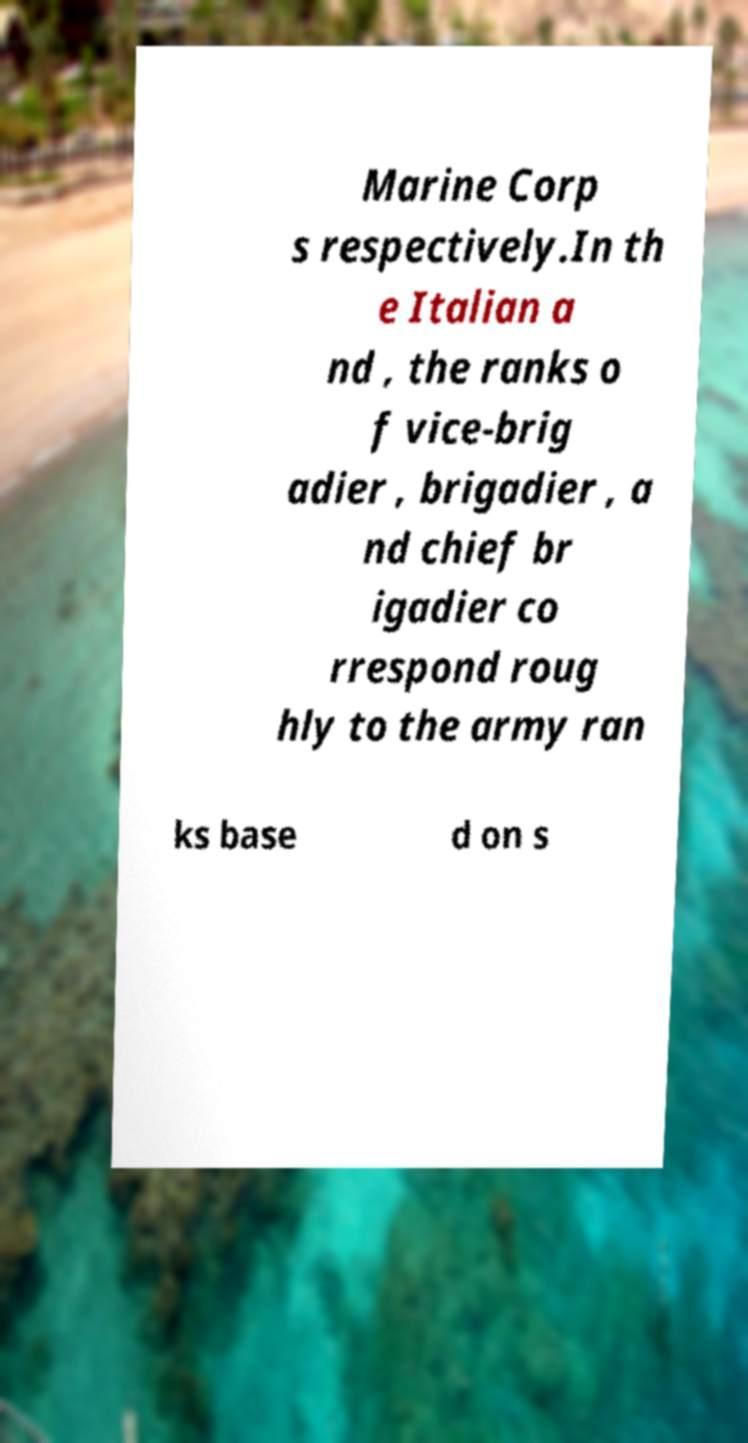Could you assist in decoding the text presented in this image and type it out clearly? Marine Corp s respectively.In th e Italian a nd , the ranks o f vice-brig adier , brigadier , a nd chief br igadier co rrespond roug hly to the army ran ks base d on s 